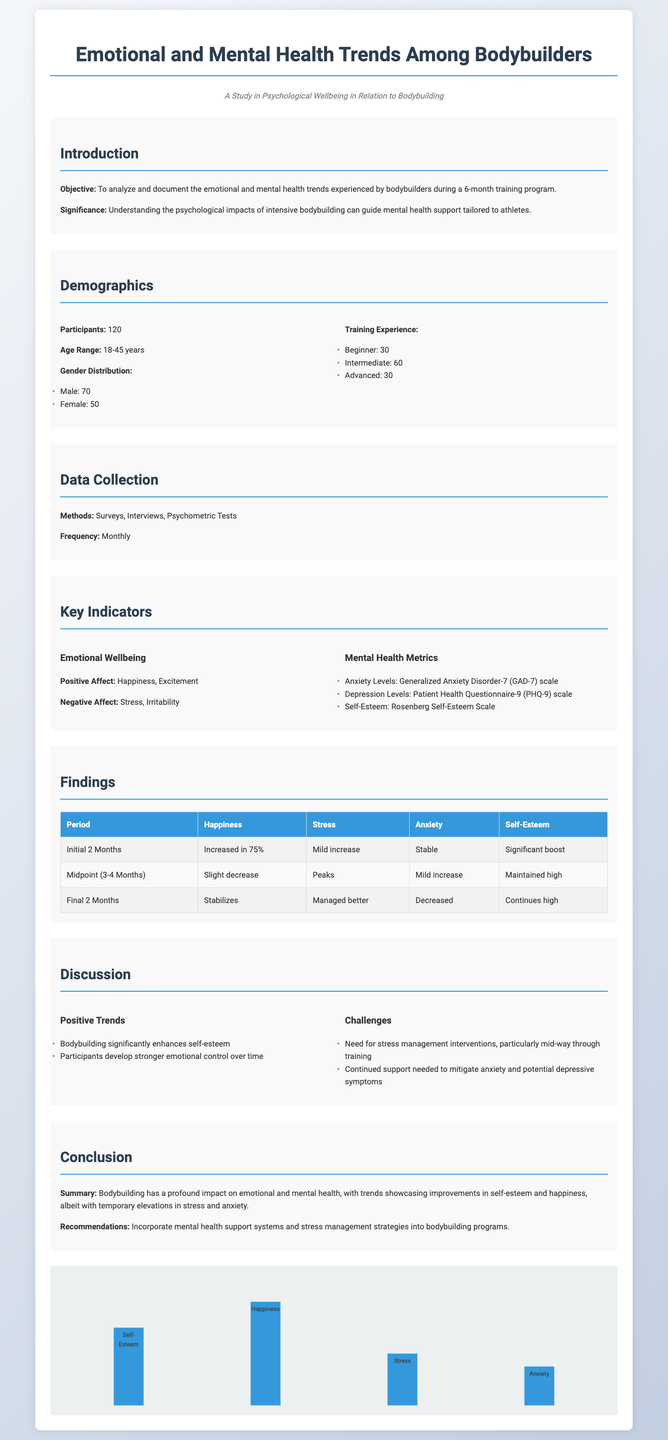What is the total number of participants? The total number of participants is stated in the document, which is 120.
Answer: 120 What is the age range of participants? The age range is provided in the demographics section, which is 18-45 years.
Answer: 18-45 years What percentage of participants experienced an increase in happiness in the initial 2 months? The document specifies that 75% of participants experienced an increase in happiness during the initial 2 months.
Answer: 75% What mental health metric is measured with the GAD-7 scale? The document indicates that Anxiety Levels are measured using the GAD-7 scale.
Answer: Anxiety Levels Which emotional wellbeing indicator saw a slight decrease during the midpoint (3-4 months)? The findings section mentions that happiness saw a slight decrease during this period.
Answer: Happiness What was the trend in stress levels during the final 2 months? The document states that stress levels were managed better in the final 2 months.
Answer: Managed better What is a significant challenge noted in the discussion? The discussion highlights the need for stress management interventions as a significant challenge.
Answer: Stress management interventions What was the conclusion regarding the impact of bodybuilding on mental health? The conclusion summarizes that bodybuilding improved self-esteem and happiness while leading to temporary increases in stress and anxiety.
Answer: Improved self-esteem and happiness 